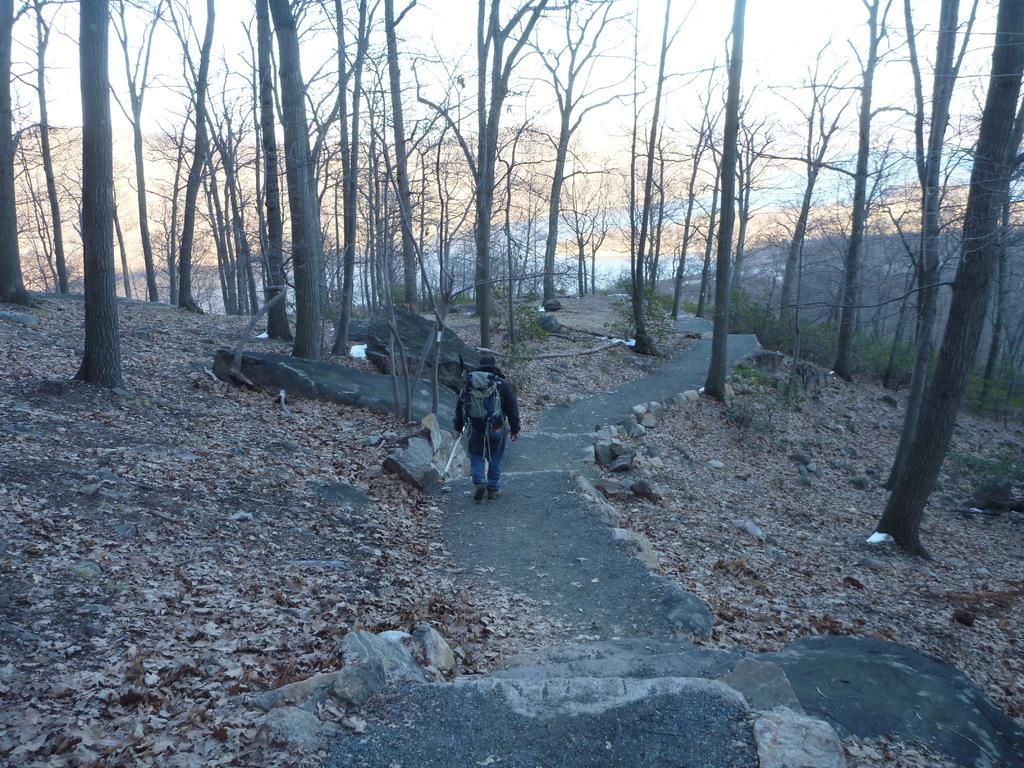In one or two sentences, can you explain what this image depicts? There is a man walking and carrying a bag and holding stick. We can see leaves, stones and trees. In the background we can see sky. 